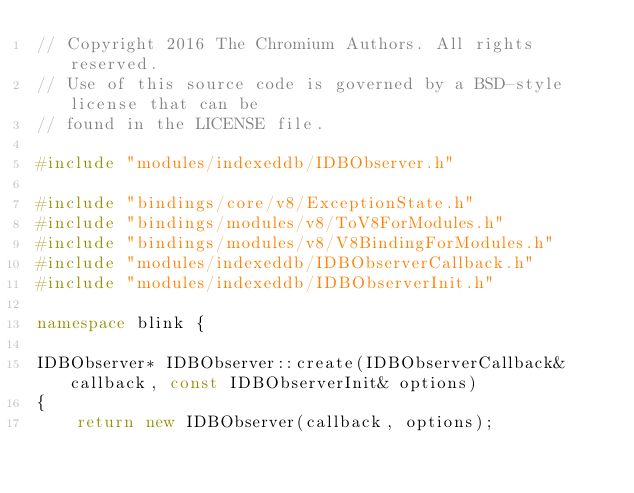Convert code to text. <code><loc_0><loc_0><loc_500><loc_500><_C++_>// Copyright 2016 The Chromium Authors. All rights reserved.
// Use of this source code is governed by a BSD-style license that can be
// found in the LICENSE file.

#include "modules/indexeddb/IDBObserver.h"

#include "bindings/core/v8/ExceptionState.h"
#include "bindings/modules/v8/ToV8ForModules.h"
#include "bindings/modules/v8/V8BindingForModules.h"
#include "modules/indexeddb/IDBObserverCallback.h"
#include "modules/indexeddb/IDBObserverInit.h"

namespace blink {

IDBObserver* IDBObserver::create(IDBObserverCallback& callback, const IDBObserverInit& options)
{
    return new IDBObserver(callback, options);</code> 